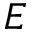Convert formula to latex. <formula><loc_0><loc_0><loc_500><loc_500>E</formula> 